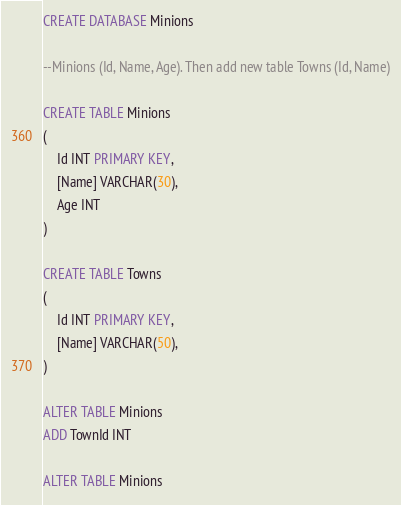<code> <loc_0><loc_0><loc_500><loc_500><_SQL_>CREATE DATABASE Minions

--Minions (Id, Name, Age). Then add new table Towns (Id, Name)

CREATE TABLE Minions
(
	Id INT PRIMARY KEY,
	[Name] VARCHAR(30),
	Age INT
)

CREATE TABLE Towns
(
	Id INT PRIMARY KEY,
	[Name] VARCHAR(50),
)

ALTER TABLE Minions
ADD TownId INT

ALTER TABLE Minions</code> 